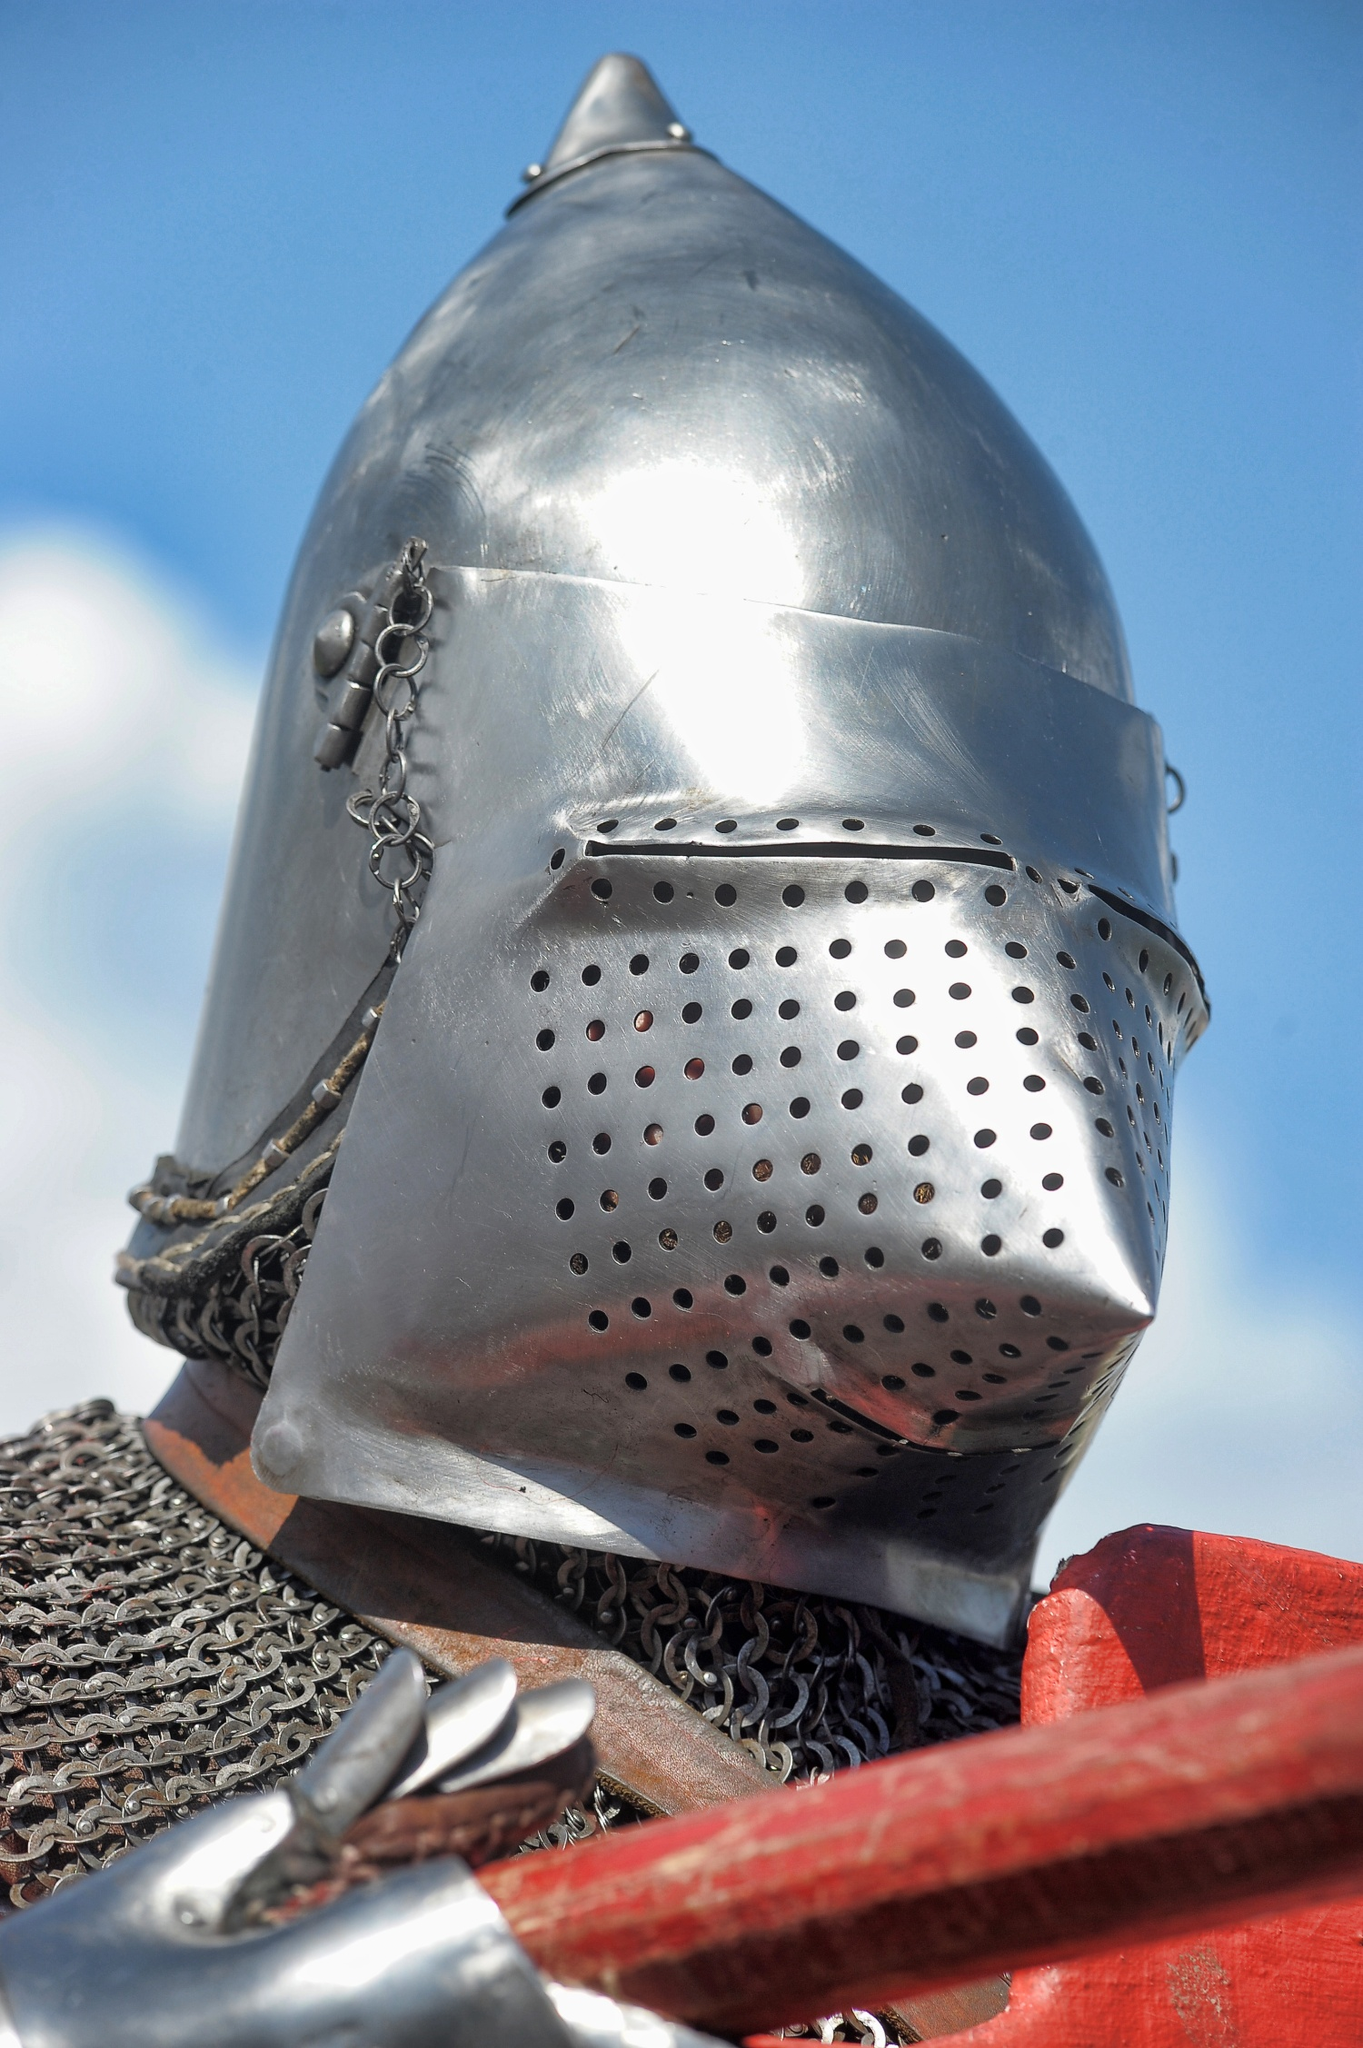Can you tell me what period this helmet might be from? The helmet in the image is a type of late medieval armet, which dates back to the 15th century. This style of helmet became prevalent in Europe, particularly among knights and men-at-arms, known for its protective features and the characteristic visor. 